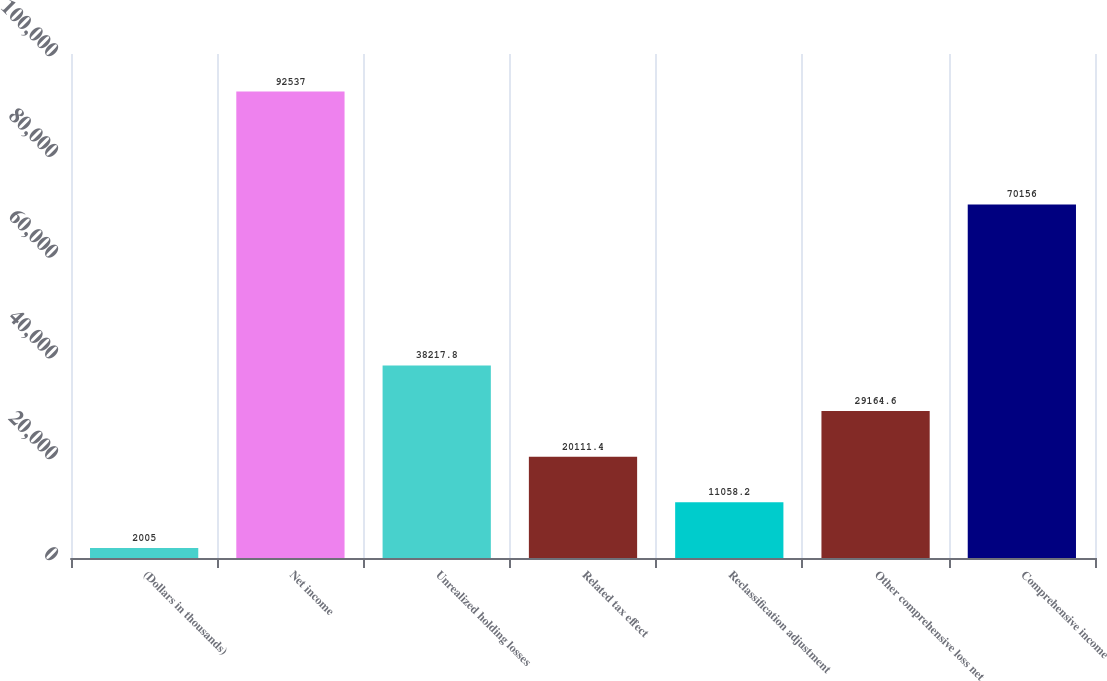<chart> <loc_0><loc_0><loc_500><loc_500><bar_chart><fcel>(Dollars in thousands)<fcel>Net income<fcel>Unrealized holding losses<fcel>Related tax effect<fcel>Reclassification adjustment<fcel>Other comprehensive loss net<fcel>Comprehensive income<nl><fcel>2005<fcel>92537<fcel>38217.8<fcel>20111.4<fcel>11058.2<fcel>29164.6<fcel>70156<nl></chart> 